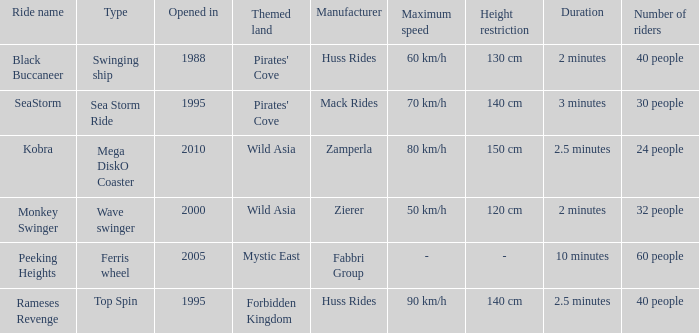What type of ride is Rameses Revenge? Top Spin. 